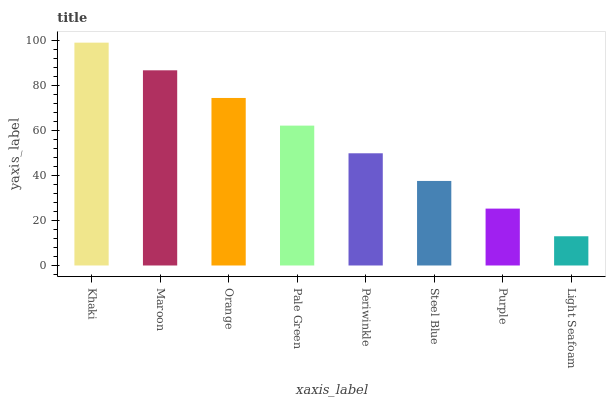Is Light Seafoam the minimum?
Answer yes or no. Yes. Is Khaki the maximum?
Answer yes or no. Yes. Is Maroon the minimum?
Answer yes or no. No. Is Maroon the maximum?
Answer yes or no. No. Is Khaki greater than Maroon?
Answer yes or no. Yes. Is Maroon less than Khaki?
Answer yes or no. Yes. Is Maroon greater than Khaki?
Answer yes or no. No. Is Khaki less than Maroon?
Answer yes or no. No. Is Pale Green the high median?
Answer yes or no. Yes. Is Periwinkle the low median?
Answer yes or no. Yes. Is Khaki the high median?
Answer yes or no. No. Is Pale Green the low median?
Answer yes or no. No. 